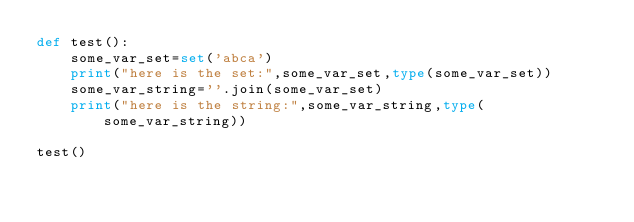Convert code to text. <code><loc_0><loc_0><loc_500><loc_500><_Python_>def test():
    some_var_set=set('abca')
    print("here is the set:",some_var_set,type(some_var_set))
    some_var_string=''.join(some_var_set)    
    print("here is the string:",some_var_string,type(some_var_string))

test()</code> 